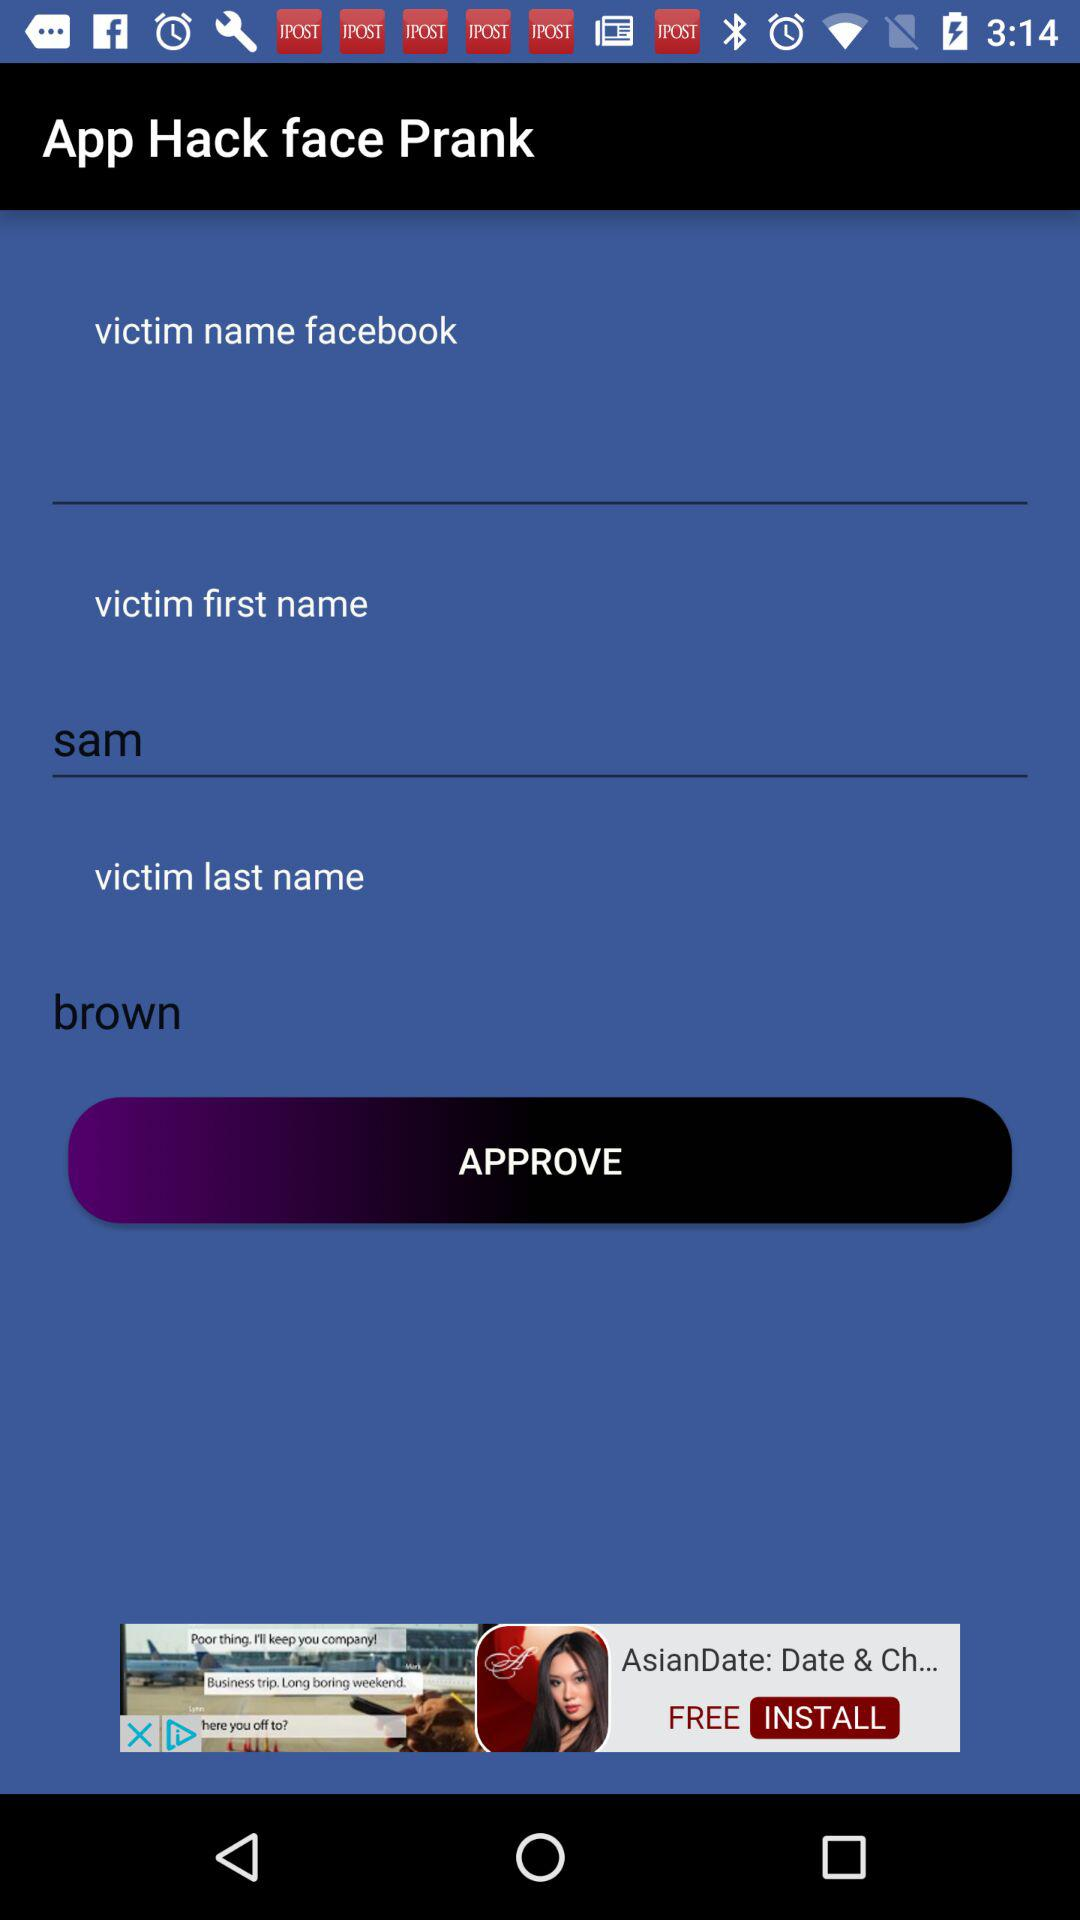What is the victim's last name? The victim's last name is Brown. 